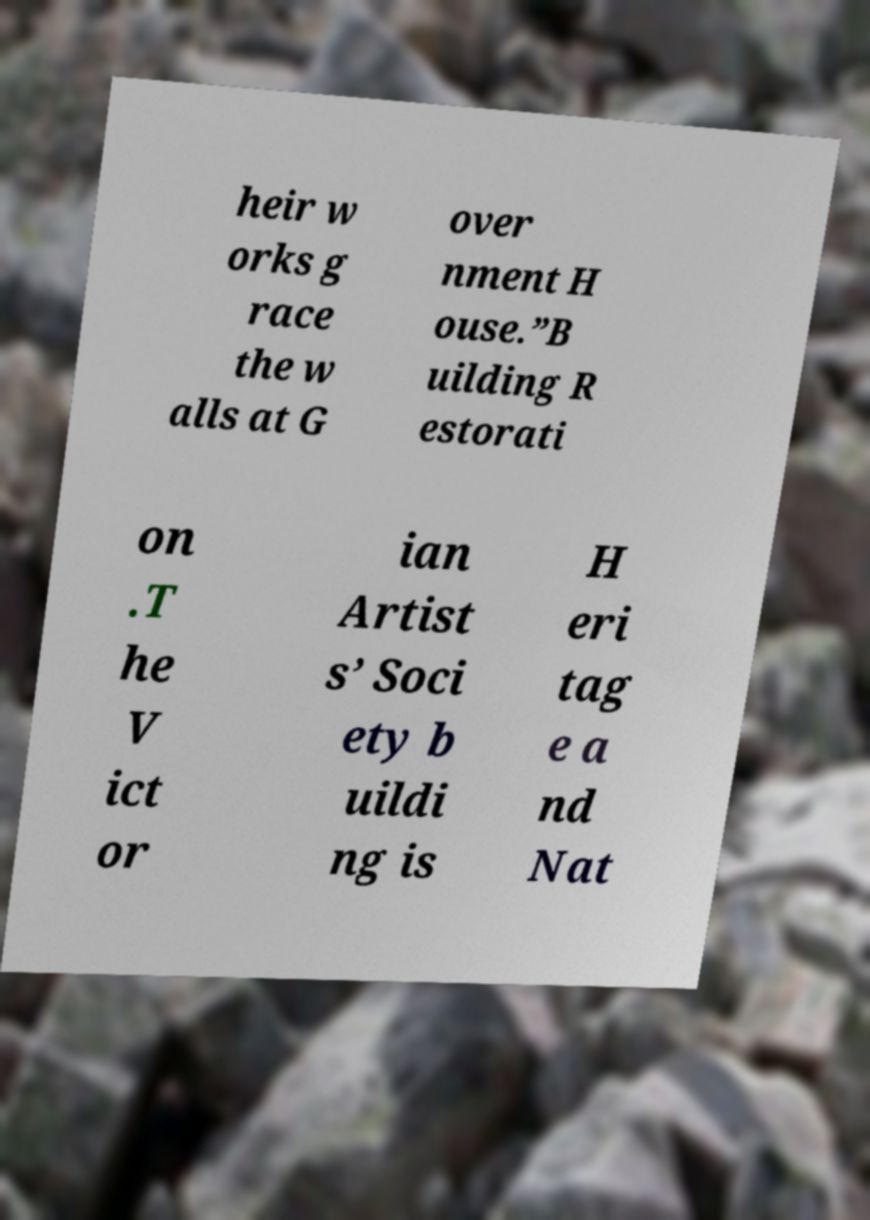Could you assist in decoding the text presented in this image and type it out clearly? heir w orks g race the w alls at G over nment H ouse.”B uilding R estorati on .T he V ict or ian Artist s’ Soci ety b uildi ng is H eri tag e a nd Nat 